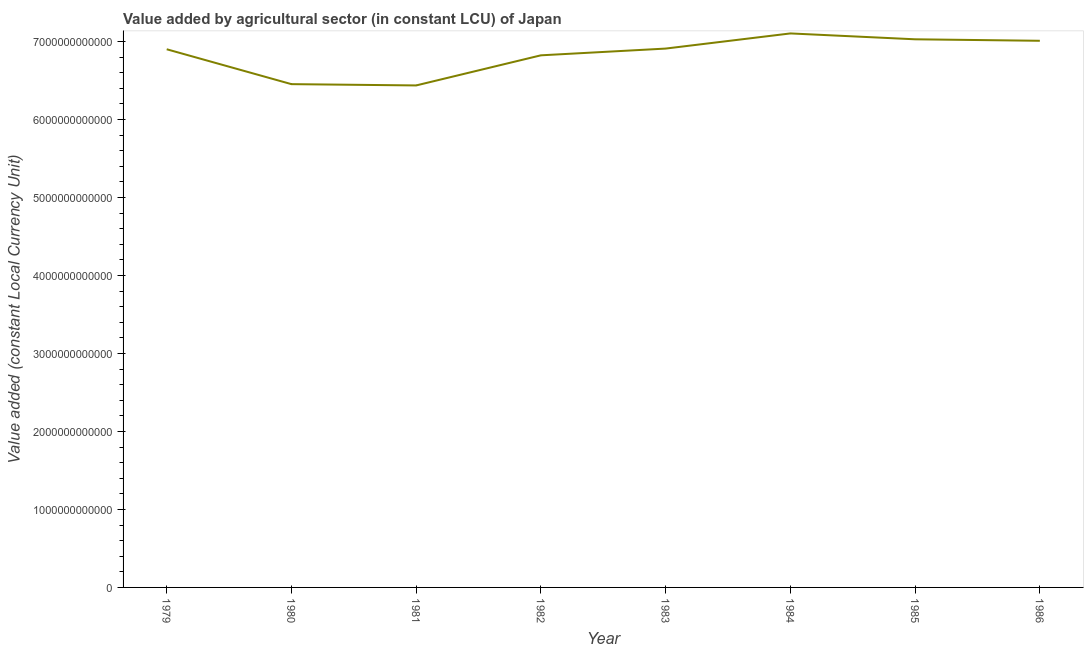What is the value added by agriculture sector in 1984?
Give a very brief answer. 7.10e+12. Across all years, what is the maximum value added by agriculture sector?
Keep it short and to the point. 7.10e+12. Across all years, what is the minimum value added by agriculture sector?
Keep it short and to the point. 6.44e+12. What is the sum of the value added by agriculture sector?
Give a very brief answer. 5.47e+13. What is the difference between the value added by agriculture sector in 1984 and 1985?
Offer a very short reply. 7.52e+1. What is the average value added by agriculture sector per year?
Make the answer very short. 6.83e+12. What is the median value added by agriculture sector?
Ensure brevity in your answer.  6.90e+12. Do a majority of the years between 1983 and 1985 (inclusive) have value added by agriculture sector greater than 1800000000000 LCU?
Offer a terse response. Yes. What is the ratio of the value added by agriculture sector in 1980 to that in 1982?
Give a very brief answer. 0.95. Is the value added by agriculture sector in 1983 less than that in 1984?
Ensure brevity in your answer.  Yes. Is the difference between the value added by agriculture sector in 1980 and 1983 greater than the difference between any two years?
Keep it short and to the point. No. What is the difference between the highest and the second highest value added by agriculture sector?
Your response must be concise. 7.52e+1. What is the difference between the highest and the lowest value added by agriculture sector?
Make the answer very short. 6.67e+11. In how many years, is the value added by agriculture sector greater than the average value added by agriculture sector taken over all years?
Keep it short and to the point. 5. Does the value added by agriculture sector monotonically increase over the years?
Give a very brief answer. No. How many lines are there?
Offer a very short reply. 1. What is the difference between two consecutive major ticks on the Y-axis?
Ensure brevity in your answer.  1.00e+12. Does the graph contain grids?
Provide a short and direct response. No. What is the title of the graph?
Provide a short and direct response. Value added by agricultural sector (in constant LCU) of Japan. What is the label or title of the Y-axis?
Your answer should be compact. Value added (constant Local Currency Unit). What is the Value added (constant Local Currency Unit) of 1979?
Offer a terse response. 6.90e+12. What is the Value added (constant Local Currency Unit) of 1980?
Offer a terse response. 6.45e+12. What is the Value added (constant Local Currency Unit) in 1981?
Offer a terse response. 6.44e+12. What is the Value added (constant Local Currency Unit) of 1982?
Ensure brevity in your answer.  6.82e+12. What is the Value added (constant Local Currency Unit) in 1983?
Your answer should be compact. 6.91e+12. What is the Value added (constant Local Currency Unit) of 1984?
Provide a short and direct response. 7.10e+12. What is the Value added (constant Local Currency Unit) of 1985?
Offer a terse response. 7.03e+12. What is the Value added (constant Local Currency Unit) of 1986?
Your answer should be very brief. 7.01e+12. What is the difference between the Value added (constant Local Currency Unit) in 1979 and 1980?
Ensure brevity in your answer.  4.47e+11. What is the difference between the Value added (constant Local Currency Unit) in 1979 and 1981?
Keep it short and to the point. 4.64e+11. What is the difference between the Value added (constant Local Currency Unit) in 1979 and 1982?
Provide a short and direct response. 7.78e+1. What is the difference between the Value added (constant Local Currency Unit) in 1979 and 1983?
Provide a short and direct response. -8.73e+09. What is the difference between the Value added (constant Local Currency Unit) in 1979 and 1984?
Give a very brief answer. -2.03e+11. What is the difference between the Value added (constant Local Currency Unit) in 1979 and 1985?
Your answer should be compact. -1.28e+11. What is the difference between the Value added (constant Local Currency Unit) in 1979 and 1986?
Ensure brevity in your answer.  -1.09e+11. What is the difference between the Value added (constant Local Currency Unit) in 1980 and 1981?
Make the answer very short. 1.65e+1. What is the difference between the Value added (constant Local Currency Unit) in 1980 and 1982?
Give a very brief answer. -3.70e+11. What is the difference between the Value added (constant Local Currency Unit) in 1980 and 1983?
Provide a short and direct response. -4.56e+11. What is the difference between the Value added (constant Local Currency Unit) in 1980 and 1984?
Your response must be concise. -6.50e+11. What is the difference between the Value added (constant Local Currency Unit) in 1980 and 1985?
Ensure brevity in your answer.  -5.75e+11. What is the difference between the Value added (constant Local Currency Unit) in 1980 and 1986?
Provide a short and direct response. -5.56e+11. What is the difference between the Value added (constant Local Currency Unit) in 1981 and 1982?
Give a very brief answer. -3.86e+11. What is the difference between the Value added (constant Local Currency Unit) in 1981 and 1983?
Your answer should be very brief. -4.73e+11. What is the difference between the Value added (constant Local Currency Unit) in 1981 and 1984?
Your response must be concise. -6.67e+11. What is the difference between the Value added (constant Local Currency Unit) in 1981 and 1985?
Your answer should be very brief. -5.92e+11. What is the difference between the Value added (constant Local Currency Unit) in 1981 and 1986?
Make the answer very short. -5.72e+11. What is the difference between the Value added (constant Local Currency Unit) in 1982 and 1983?
Provide a succinct answer. -8.65e+1. What is the difference between the Value added (constant Local Currency Unit) in 1982 and 1984?
Keep it short and to the point. -2.81e+11. What is the difference between the Value added (constant Local Currency Unit) in 1982 and 1985?
Make the answer very short. -2.05e+11. What is the difference between the Value added (constant Local Currency Unit) in 1982 and 1986?
Keep it short and to the point. -1.86e+11. What is the difference between the Value added (constant Local Currency Unit) in 1983 and 1984?
Your response must be concise. -1.94e+11. What is the difference between the Value added (constant Local Currency Unit) in 1983 and 1985?
Make the answer very short. -1.19e+11. What is the difference between the Value added (constant Local Currency Unit) in 1983 and 1986?
Make the answer very short. -1.00e+11. What is the difference between the Value added (constant Local Currency Unit) in 1984 and 1985?
Your answer should be very brief. 7.52e+1. What is the difference between the Value added (constant Local Currency Unit) in 1984 and 1986?
Your response must be concise. 9.43e+1. What is the difference between the Value added (constant Local Currency Unit) in 1985 and 1986?
Provide a short and direct response. 1.90e+1. What is the ratio of the Value added (constant Local Currency Unit) in 1979 to that in 1980?
Your answer should be very brief. 1.07. What is the ratio of the Value added (constant Local Currency Unit) in 1979 to that in 1981?
Provide a succinct answer. 1.07. What is the ratio of the Value added (constant Local Currency Unit) in 1979 to that in 1982?
Keep it short and to the point. 1.01. What is the ratio of the Value added (constant Local Currency Unit) in 1979 to that in 1983?
Give a very brief answer. 1. What is the ratio of the Value added (constant Local Currency Unit) in 1979 to that in 1984?
Make the answer very short. 0.97. What is the ratio of the Value added (constant Local Currency Unit) in 1979 to that in 1986?
Keep it short and to the point. 0.98. What is the ratio of the Value added (constant Local Currency Unit) in 1980 to that in 1981?
Your answer should be very brief. 1. What is the ratio of the Value added (constant Local Currency Unit) in 1980 to that in 1982?
Offer a very short reply. 0.95. What is the ratio of the Value added (constant Local Currency Unit) in 1980 to that in 1983?
Make the answer very short. 0.93. What is the ratio of the Value added (constant Local Currency Unit) in 1980 to that in 1984?
Offer a terse response. 0.91. What is the ratio of the Value added (constant Local Currency Unit) in 1980 to that in 1985?
Your answer should be compact. 0.92. What is the ratio of the Value added (constant Local Currency Unit) in 1980 to that in 1986?
Make the answer very short. 0.92. What is the ratio of the Value added (constant Local Currency Unit) in 1981 to that in 1982?
Your answer should be compact. 0.94. What is the ratio of the Value added (constant Local Currency Unit) in 1981 to that in 1983?
Offer a terse response. 0.93. What is the ratio of the Value added (constant Local Currency Unit) in 1981 to that in 1984?
Provide a short and direct response. 0.91. What is the ratio of the Value added (constant Local Currency Unit) in 1981 to that in 1985?
Your answer should be compact. 0.92. What is the ratio of the Value added (constant Local Currency Unit) in 1981 to that in 1986?
Keep it short and to the point. 0.92. What is the ratio of the Value added (constant Local Currency Unit) in 1982 to that in 1983?
Keep it short and to the point. 0.99. What is the ratio of the Value added (constant Local Currency Unit) in 1982 to that in 1985?
Offer a very short reply. 0.97. What is the ratio of the Value added (constant Local Currency Unit) in 1983 to that in 1984?
Your answer should be very brief. 0.97. What is the ratio of the Value added (constant Local Currency Unit) in 1983 to that in 1986?
Give a very brief answer. 0.99. What is the ratio of the Value added (constant Local Currency Unit) in 1984 to that in 1986?
Make the answer very short. 1.01. What is the ratio of the Value added (constant Local Currency Unit) in 1985 to that in 1986?
Give a very brief answer. 1. 